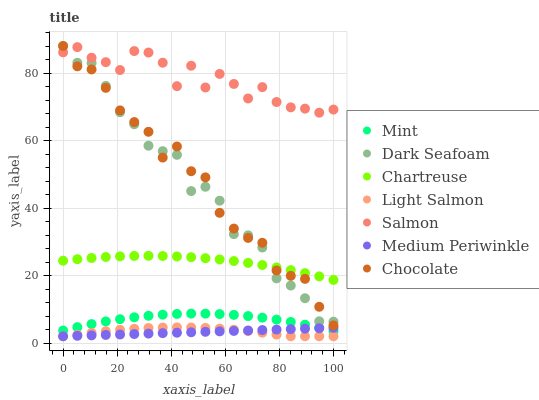Does Medium Periwinkle have the minimum area under the curve?
Answer yes or no. Yes. Does Salmon have the maximum area under the curve?
Answer yes or no. Yes. Does Salmon have the minimum area under the curve?
Answer yes or no. No. Does Medium Periwinkle have the maximum area under the curve?
Answer yes or no. No. Is Medium Periwinkle the smoothest?
Answer yes or no. Yes. Is Salmon the roughest?
Answer yes or no. Yes. Is Salmon the smoothest?
Answer yes or no. No. Is Medium Periwinkle the roughest?
Answer yes or no. No. Does Light Salmon have the lowest value?
Answer yes or no. Yes. Does Salmon have the lowest value?
Answer yes or no. No. Does Dark Seafoam have the highest value?
Answer yes or no. Yes. Does Salmon have the highest value?
Answer yes or no. No. Is Mint less than Chartreuse?
Answer yes or no. Yes. Is Chartreuse greater than Mint?
Answer yes or no. Yes. Does Mint intersect Medium Periwinkle?
Answer yes or no. Yes. Is Mint less than Medium Periwinkle?
Answer yes or no. No. Is Mint greater than Medium Periwinkle?
Answer yes or no. No. Does Mint intersect Chartreuse?
Answer yes or no. No. 